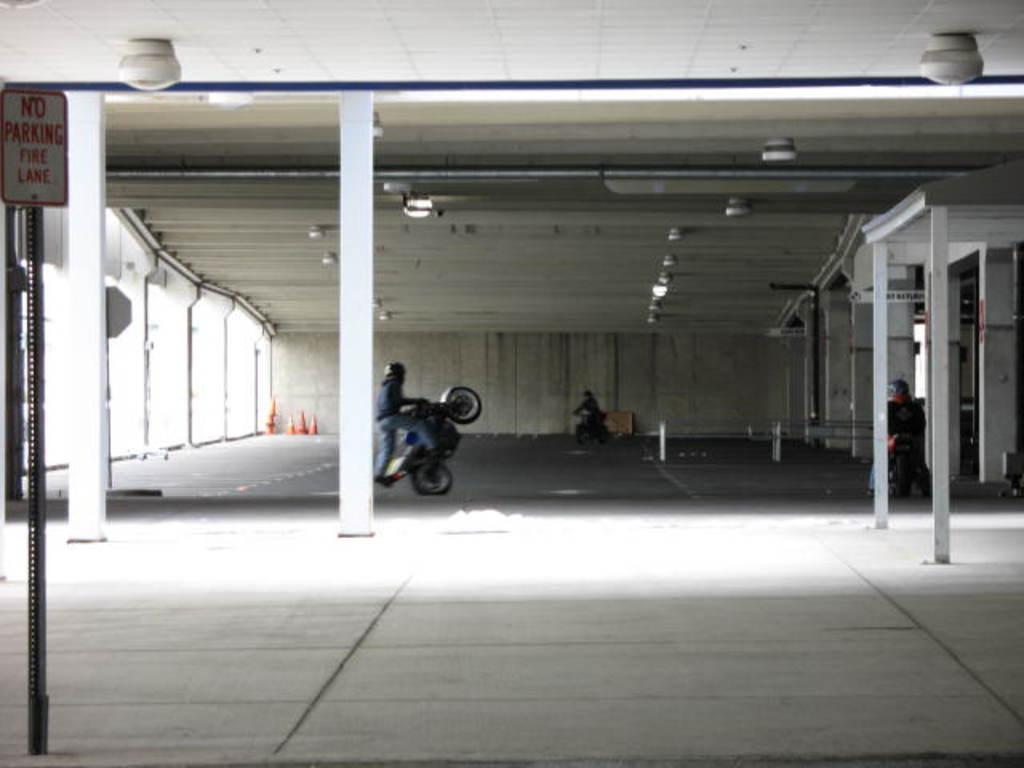Describe this image in one or two sentences. In this image we can see the inner view of the building and there are three people riding a motor bike. On the left side, we can see a signboard with some text and there are some lights. 